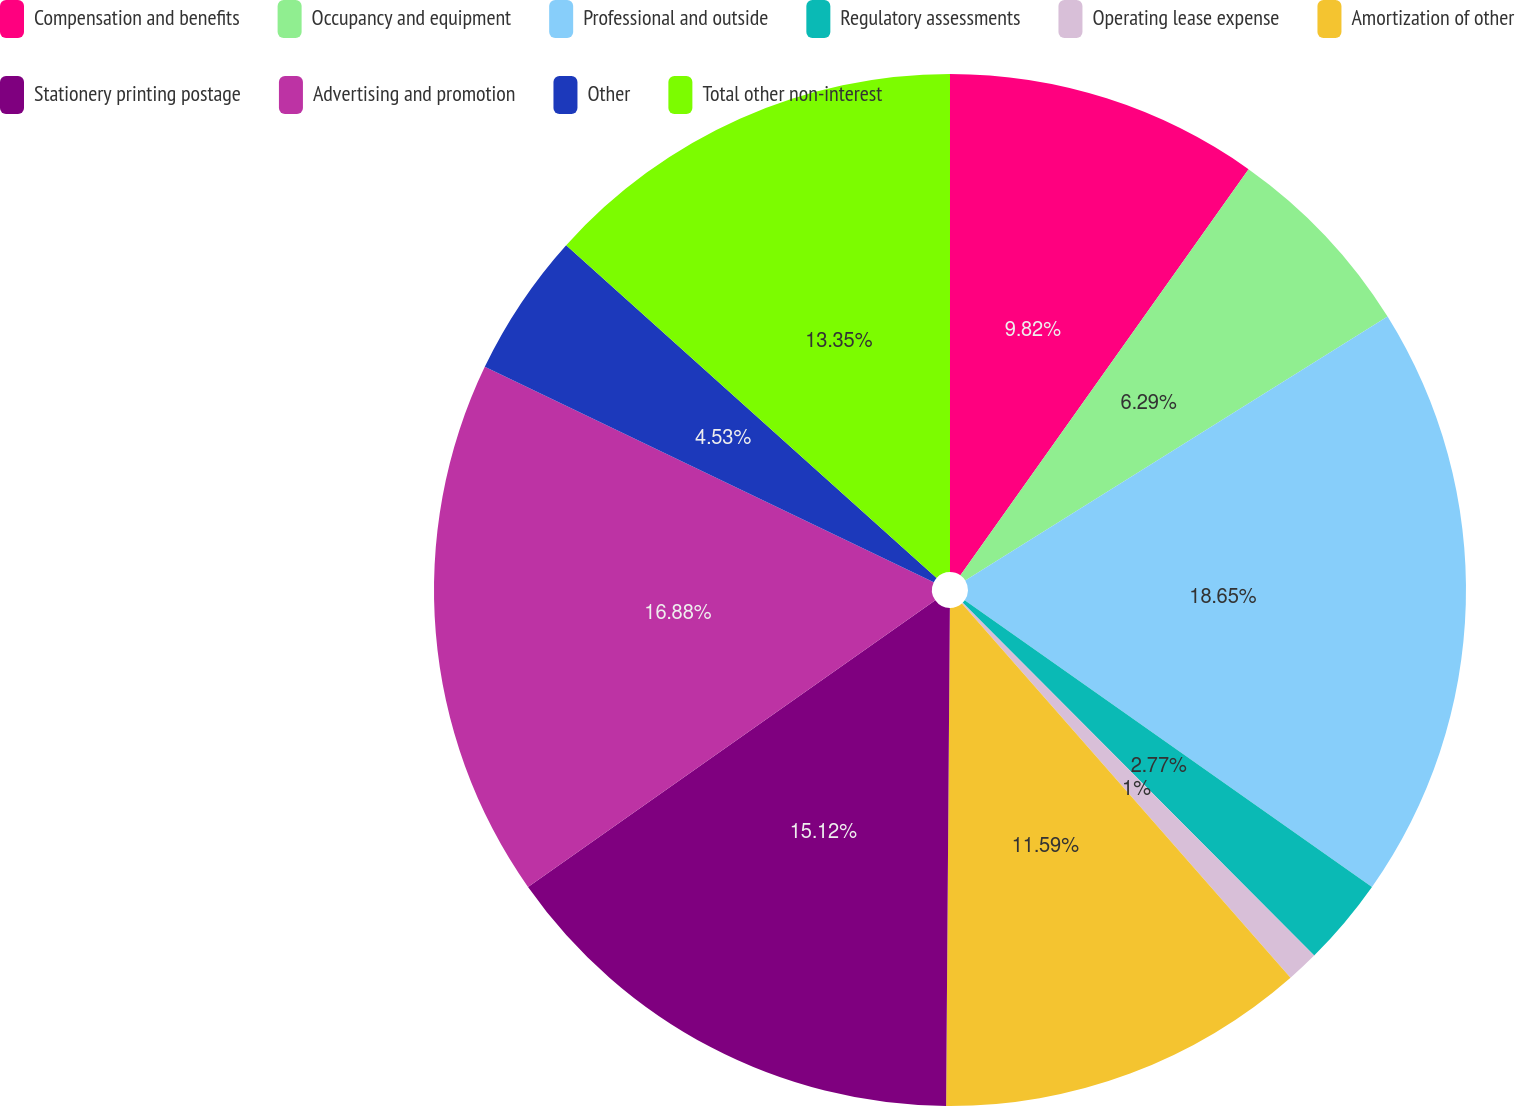<chart> <loc_0><loc_0><loc_500><loc_500><pie_chart><fcel>Compensation and benefits<fcel>Occupancy and equipment<fcel>Professional and outside<fcel>Regulatory assessments<fcel>Operating lease expense<fcel>Amortization of other<fcel>Stationery printing postage<fcel>Advertising and promotion<fcel>Other<fcel>Total other non-interest<nl><fcel>9.82%<fcel>6.29%<fcel>18.65%<fcel>2.77%<fcel>1.0%<fcel>11.59%<fcel>15.12%<fcel>16.88%<fcel>4.53%<fcel>13.35%<nl></chart> 